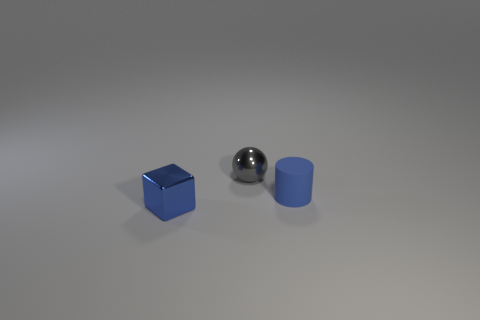Add 1 small red objects. How many objects exist? 4 Subtract all spheres. How many objects are left? 2 Subtract all small rubber objects. Subtract all rubber cylinders. How many objects are left? 1 Add 1 small gray shiny objects. How many small gray shiny objects are left? 2 Add 3 small purple rubber balls. How many small purple rubber balls exist? 3 Subtract 0 red cylinders. How many objects are left? 3 